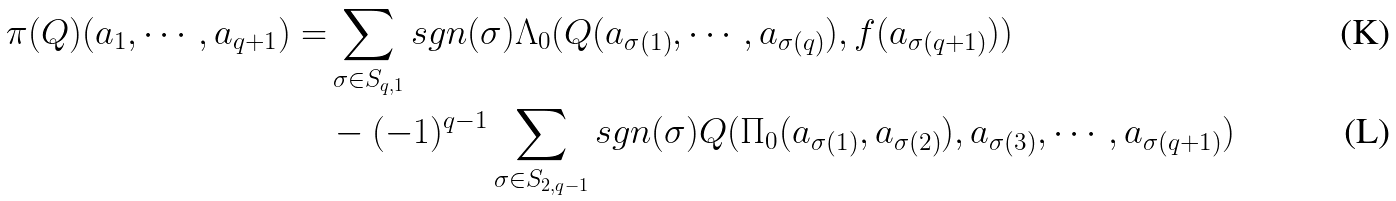<formula> <loc_0><loc_0><loc_500><loc_500>\pi ( Q ) ( a _ { 1 } , \cdots , a _ { q + 1 } ) = & \sum _ { \sigma \in S _ { q , 1 } } s g n ( \sigma ) \Lambda _ { 0 } ( Q ( a _ { \sigma ( 1 ) } , \cdots , a _ { \sigma ( q ) } ) , f ( a _ { \sigma ( q + 1 ) } ) ) \\ & - ( - 1 ) ^ { q - 1 } \sum _ { \sigma \in S _ { 2 , q - 1 } } s g n ( \sigma ) Q ( \Pi _ { 0 } ( a _ { \sigma ( 1 ) } , a _ { \sigma ( 2 ) } ) , a _ { \sigma ( 3 ) } , \cdots , a _ { \sigma ( q + 1 ) } )</formula> 